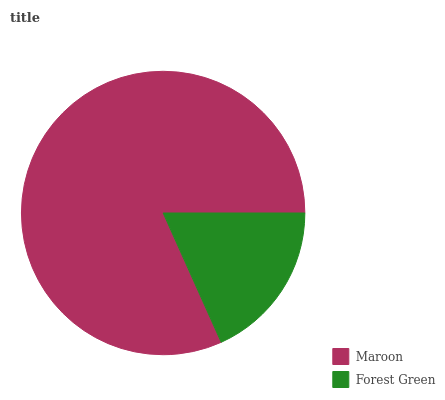Is Forest Green the minimum?
Answer yes or no. Yes. Is Maroon the maximum?
Answer yes or no. Yes. Is Forest Green the maximum?
Answer yes or no. No. Is Maroon greater than Forest Green?
Answer yes or no. Yes. Is Forest Green less than Maroon?
Answer yes or no. Yes. Is Forest Green greater than Maroon?
Answer yes or no. No. Is Maroon less than Forest Green?
Answer yes or no. No. Is Maroon the high median?
Answer yes or no. Yes. Is Forest Green the low median?
Answer yes or no. Yes. Is Forest Green the high median?
Answer yes or no. No. Is Maroon the low median?
Answer yes or no. No. 